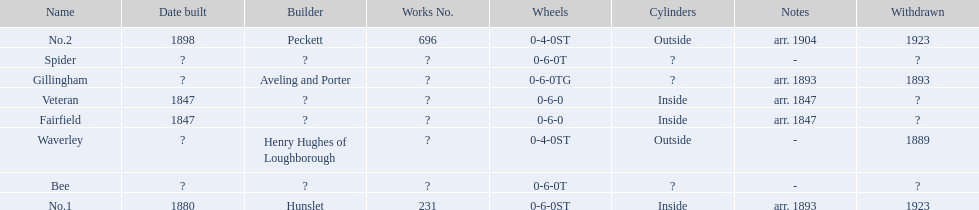What are the alderney railway names? Veteran, Fairfield, Waverley, Bee, Spider, Gillingham, No.1, No.2. When was the farfield built? 1847. What else was built that year? Veteran. 